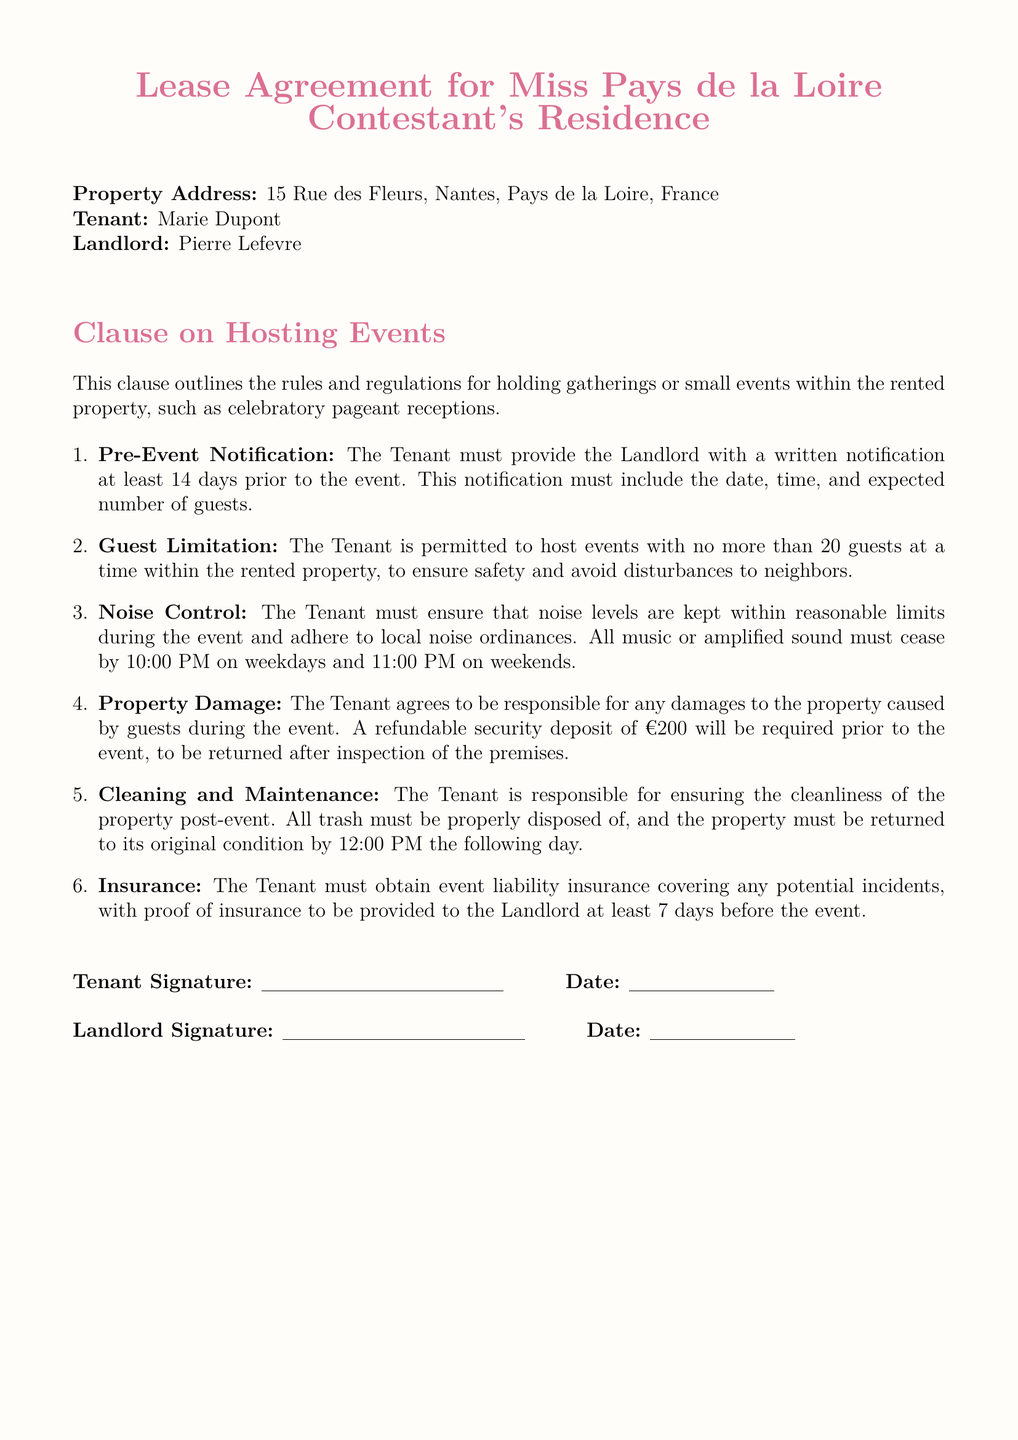What is the property address? The property address is listed at the beginning of the document under "Property Address."
Answer: 15 Rue des Fleurs, Nantes, Pays de la Loire, France Who is the tenant? The tenant's name is mentioned in the "Tenant" section of the document.
Answer: Marie Dupont How many guests can the tenant host at an event? The "Guest Limitation" section specifies the maximum number of guests allowed during an event.
Answer: 20 guests What is the noise ordinance closing time on weekdays? The "Noise Control" section details the ending time for music or amplified sound on weekdays.
Answer: 10:00 PM What is the refundable security deposit amount? The amount for the security deposit is stated in the "Property Damage" section of the document.
Answer: €200 What must the tenant obtain before hosting an event? The "Insurance" section outlines what the tenant must secure prior to the event.
Answer: Event liability insurance When is the cleaning deadline after an event? The "Cleaning and Maintenance" section stipulates the time by which the property must be returned to its original condition.
Answer: 12:00 PM the following day What is required to be included in the pre-event notification? The "Pre-Event Notification" section specifies what information must be included in the notification to the landlord.
Answer: Date, time, and expected number of guests 